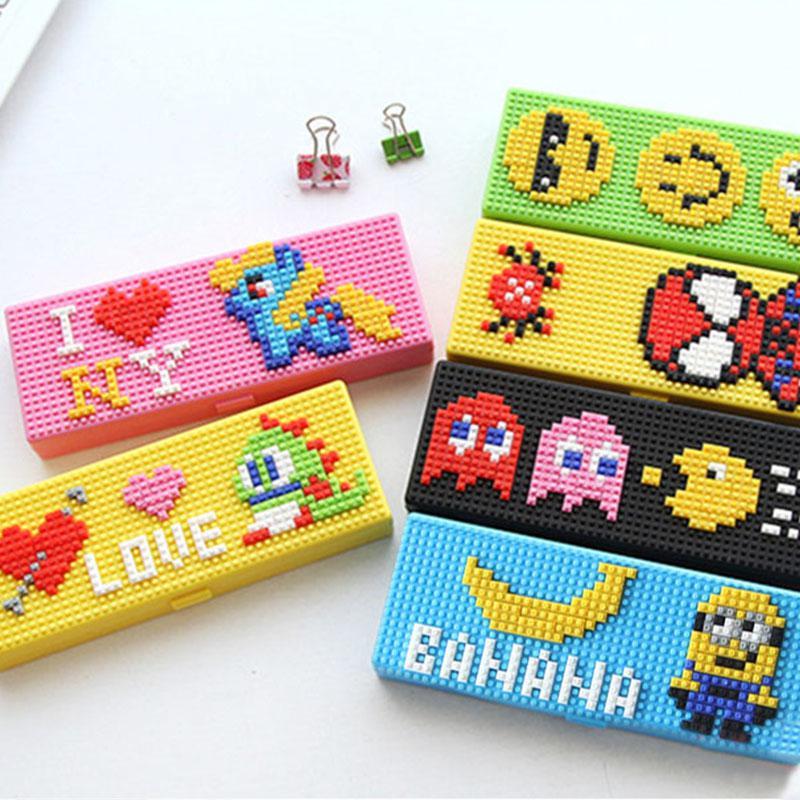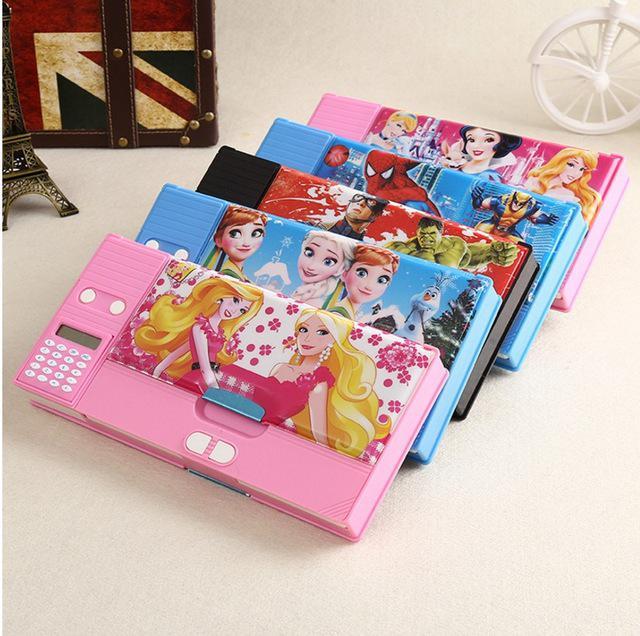The first image is the image on the left, the second image is the image on the right. Analyze the images presented: Is the assertion "In one of the images, three pencils are sticking out of the front pocket on the pencil case." valid? Answer yes or no. No. The first image is the image on the left, the second image is the image on the right. For the images displayed, is the sentence "There are two pencil cases in the image on the right." factually correct? Answer yes or no. No. The first image is the image on the left, the second image is the image on the right. For the images displayed, is the sentence "An image includes a flat case with a zig-zag pattern and yellow pencils sticking out of its front pocket." factually correct? Answer yes or no. No. 